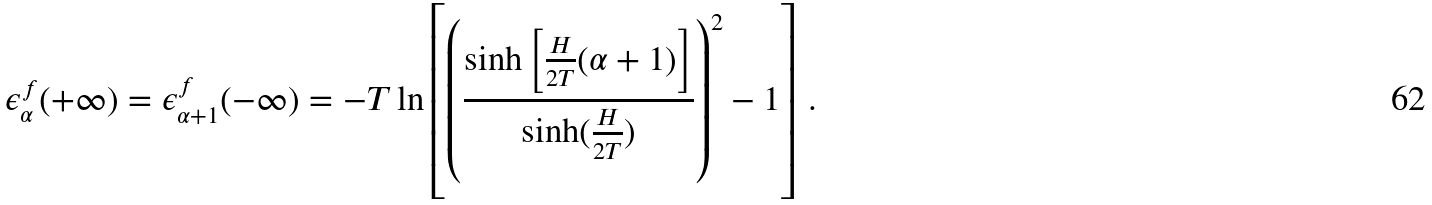<formula> <loc_0><loc_0><loc_500><loc_500>\epsilon _ { \alpha } ^ { f } ( + \infty ) = \epsilon _ { \alpha + 1 } ^ { f } ( - \infty ) = - T \ln \left [ \left ( \frac { \sinh \left [ \frac { H } { 2 T } ( \alpha + 1 ) \right ] } { \sinh ( \frac { H } { 2 T } ) } \right ) ^ { 2 } - 1 \right ] \, .</formula> 